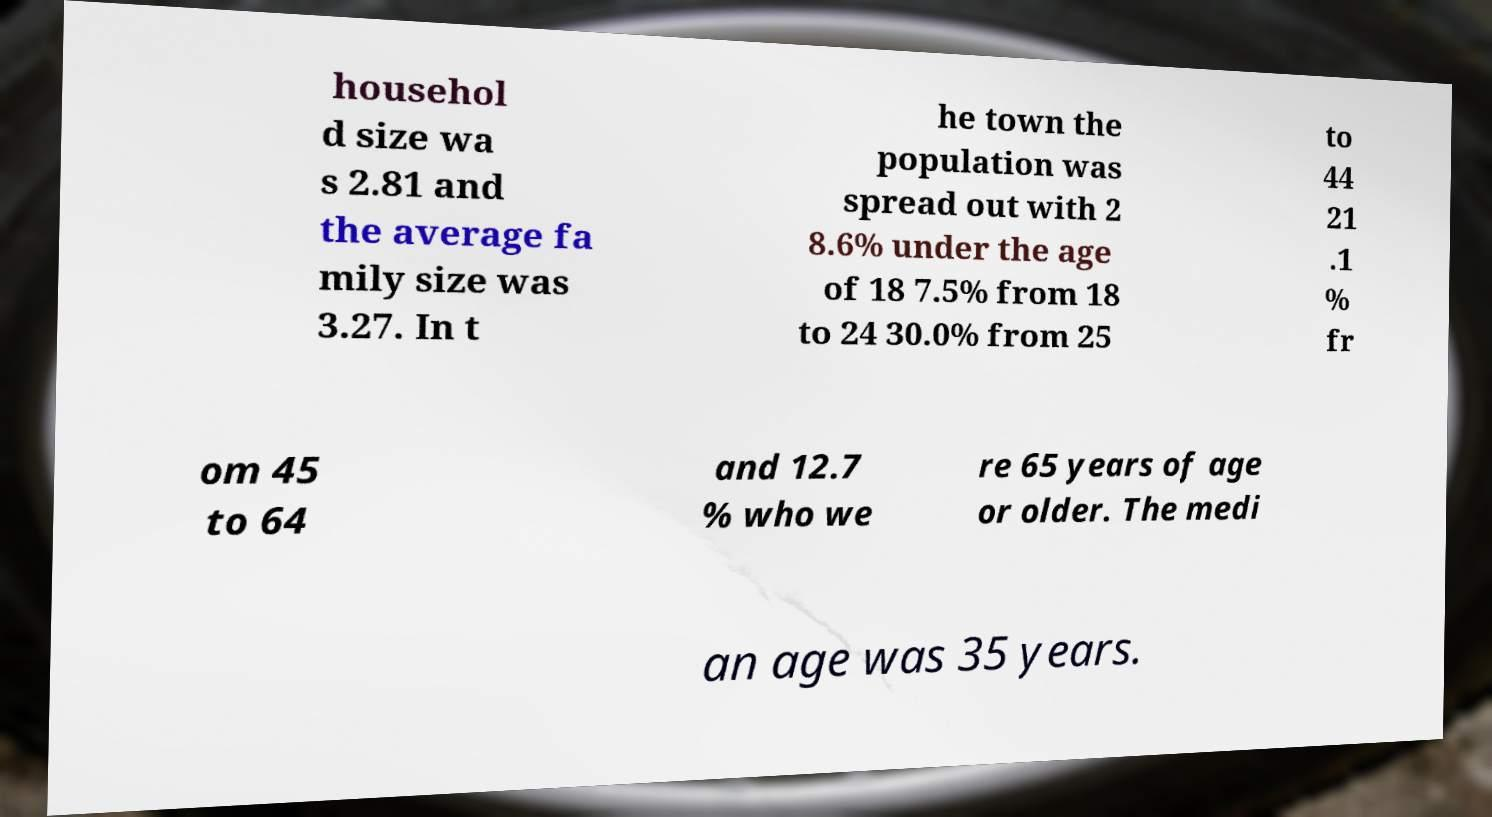Please read and relay the text visible in this image. What does it say? househol d size wa s 2.81 and the average fa mily size was 3.27. In t he town the population was spread out with 2 8.6% under the age of 18 7.5% from 18 to 24 30.0% from 25 to 44 21 .1 % fr om 45 to 64 and 12.7 % who we re 65 years of age or older. The medi an age was 35 years. 